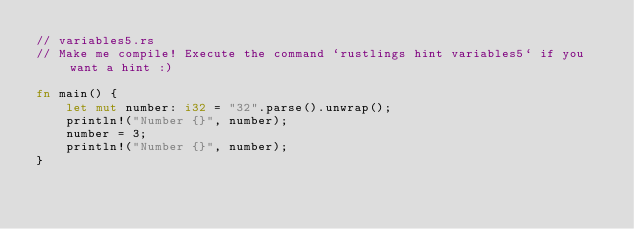Convert code to text. <code><loc_0><loc_0><loc_500><loc_500><_Rust_>// variables5.rs
// Make me compile! Execute the command `rustlings hint variables5` if you want a hint :)

fn main() {
    let mut number: i32 = "32".parse().unwrap();
    println!("Number {}", number);
    number = 3;
    println!("Number {}", number);
}
</code> 